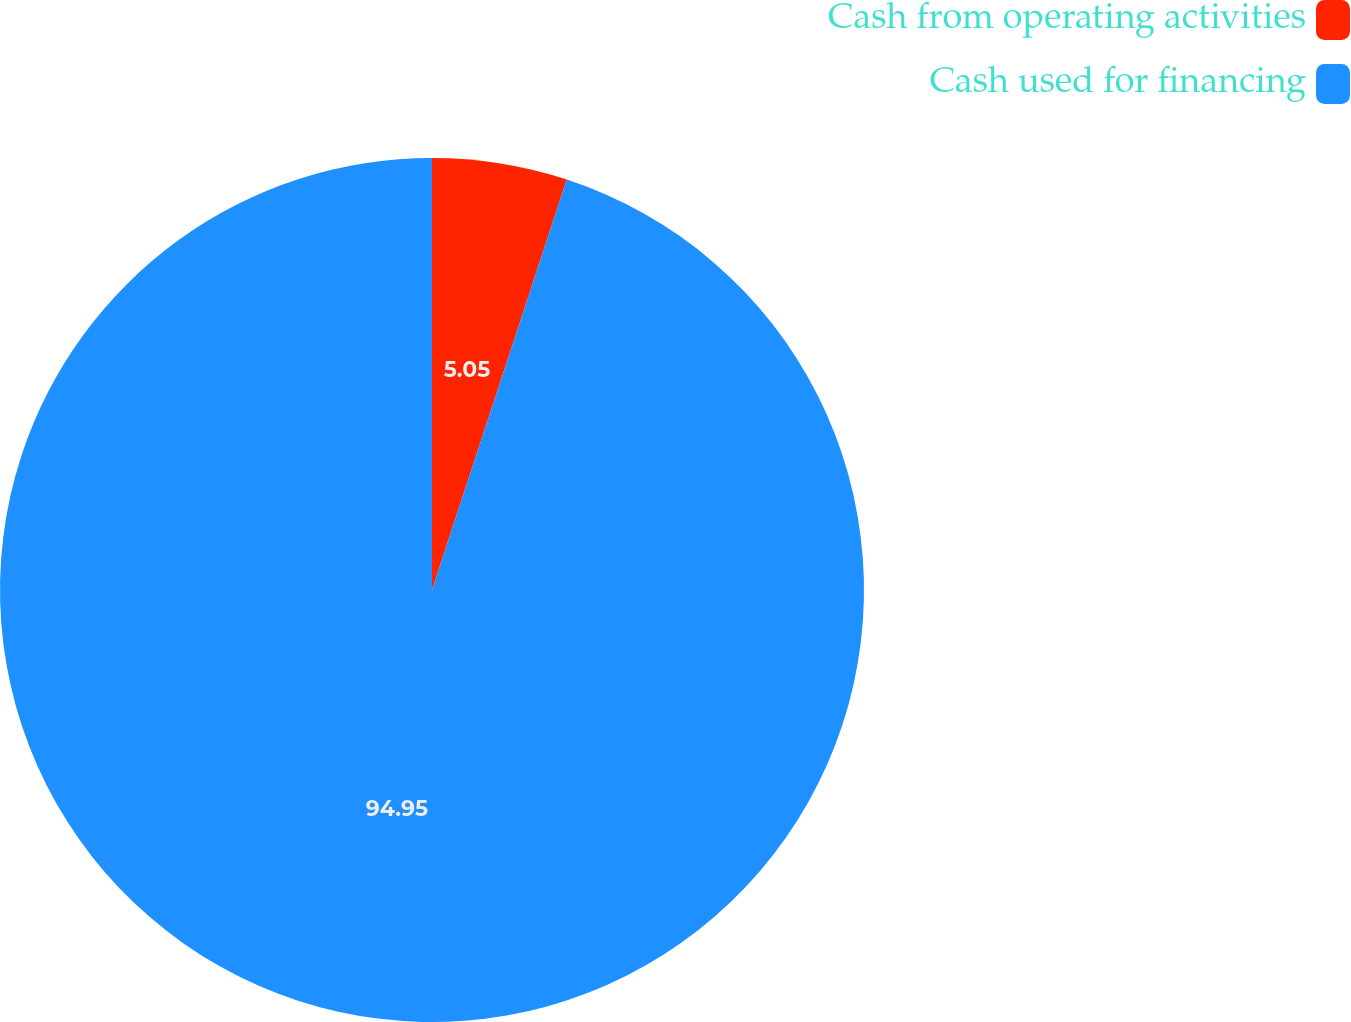<chart> <loc_0><loc_0><loc_500><loc_500><pie_chart><fcel>Cash from operating activities<fcel>Cash used for financing<nl><fcel>5.05%<fcel>94.95%<nl></chart> 